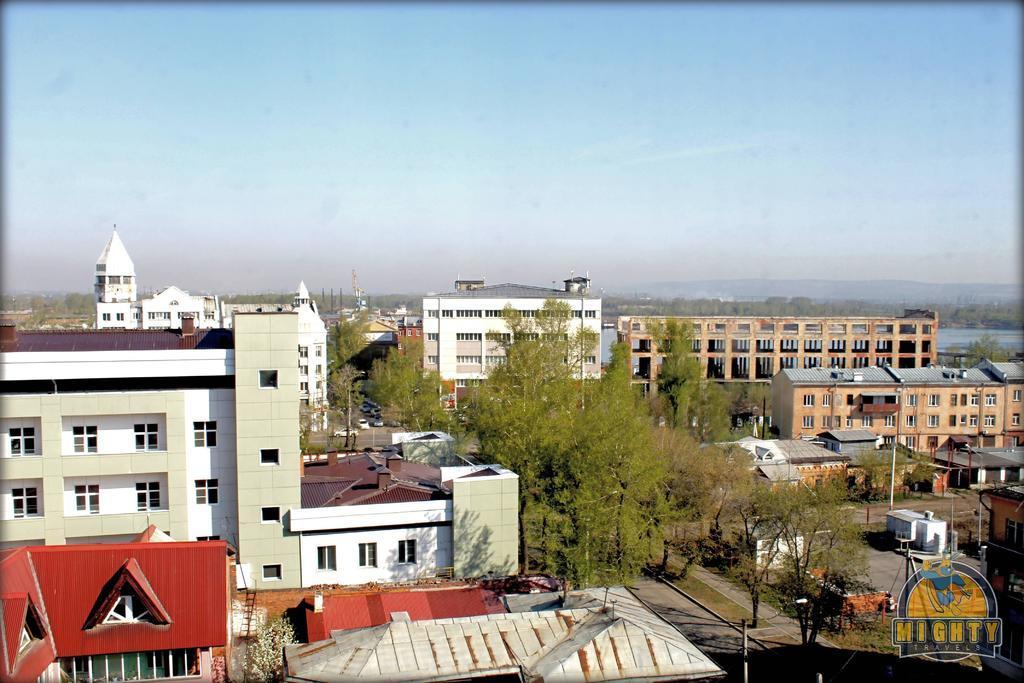Can you describe this image briefly? In this image I see buildings, trees and I can also see few poles and I see the road and I see few cars over here. In the background I see the clear sky. 